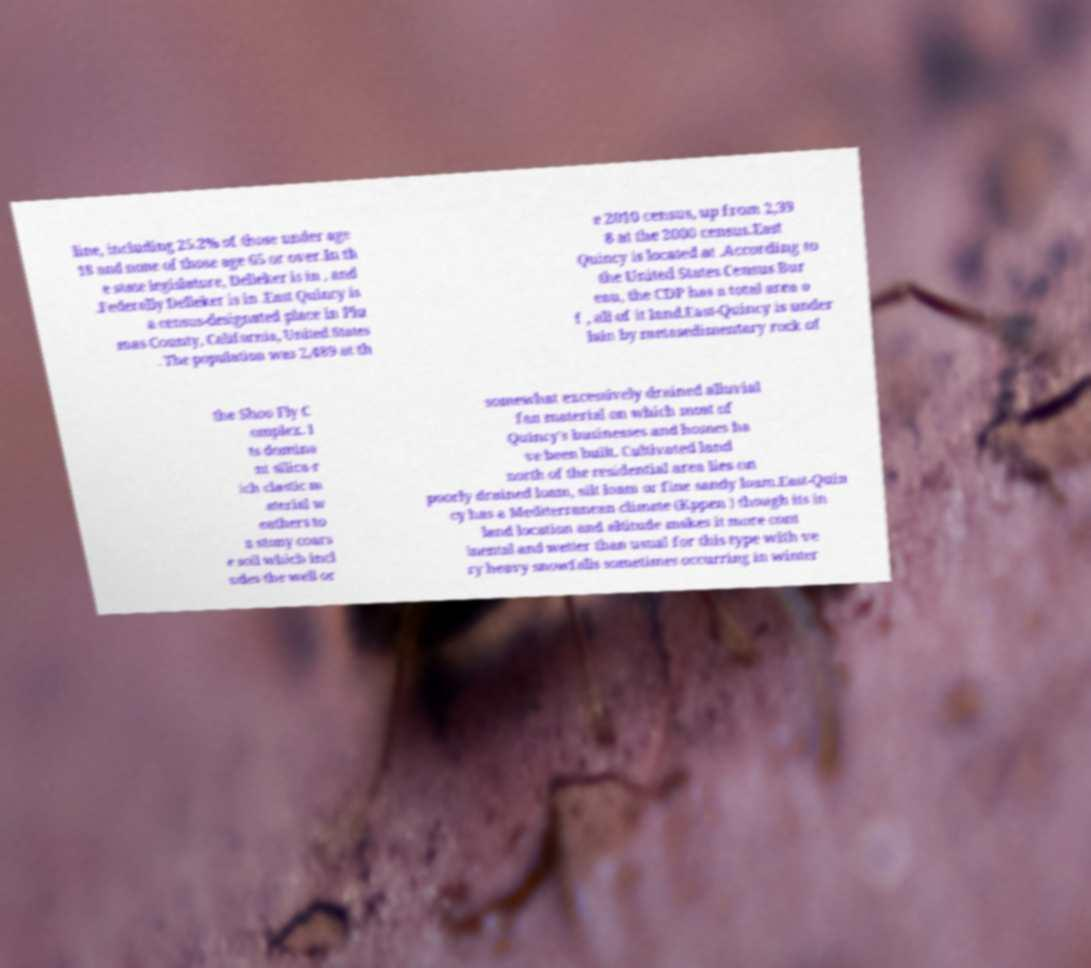Could you extract and type out the text from this image? line, including 25.2% of those under age 18 and none of those age 65 or over.In th e state legislature, Delleker is in , and .Federally Delleker is in .East Quincy is a census-designated place in Plu mas County, California, United States . The population was 2,489 at th e 2010 census, up from 2,39 8 at the 2000 census.East Quincy is located at .According to the United States Census Bur eau, the CDP has a total area o f , all of it land.East-Quincy is under lain by metasedimentary rock of the Shoo Fly C omplex. I ts domina nt silica-r ich clastic m aterial w eathers to a stony coars e soil which incl udes the well or somewhat excessively drained alluvial fan material on which most of Quincy's businesses and homes ha ve been built. Cultivated land north of the residential area lies on poorly drained loam, silt loam or fine sandy loam.East-Quin cy has a Mediterranean climate (Kppen ) though its in land location and altitude makes it more cont inental and wetter than usual for this type with ve ry heavy snowfalls sometimes occurring in winter 